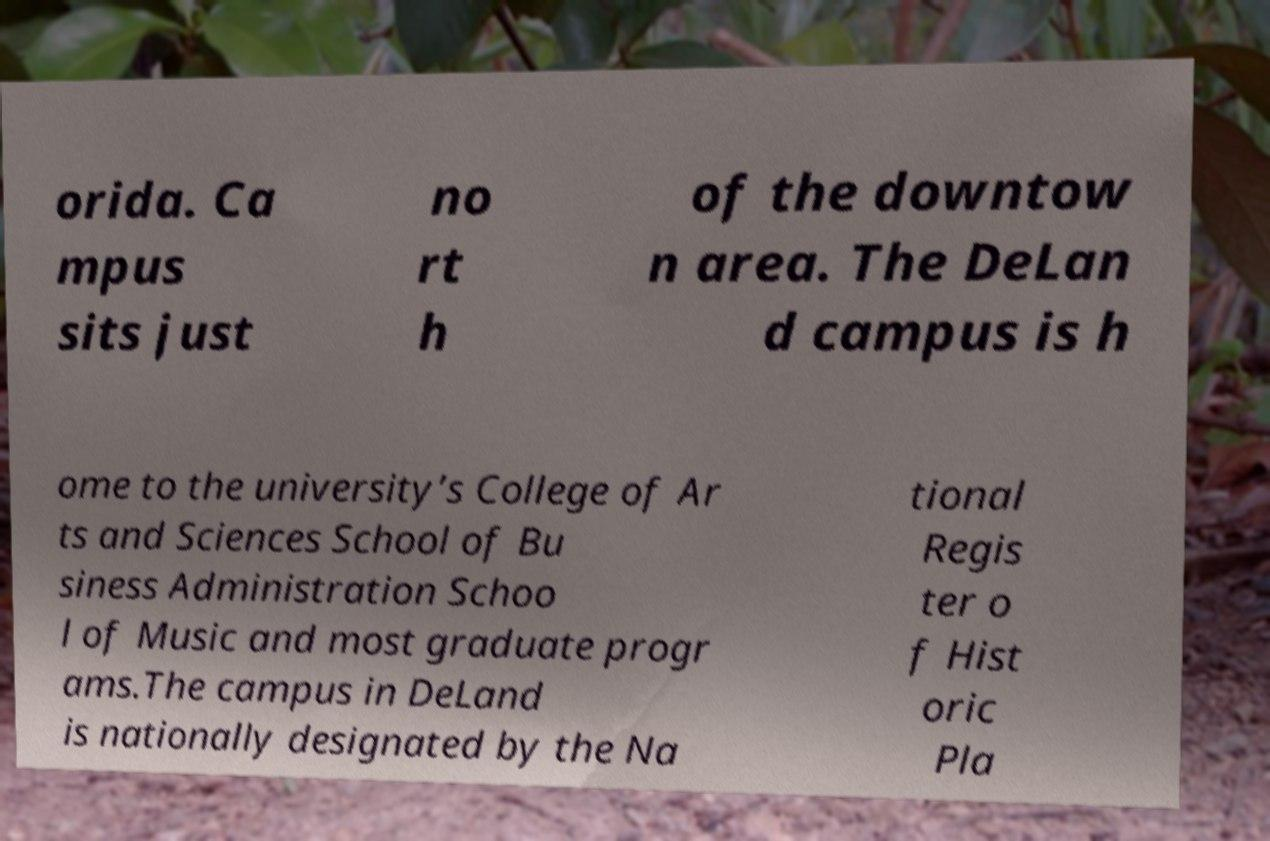Could you assist in decoding the text presented in this image and type it out clearly? orida. Ca mpus sits just no rt h of the downtow n area. The DeLan d campus is h ome to the university’s College of Ar ts and Sciences School of Bu siness Administration Schoo l of Music and most graduate progr ams.The campus in DeLand is nationally designated by the Na tional Regis ter o f Hist oric Pla 